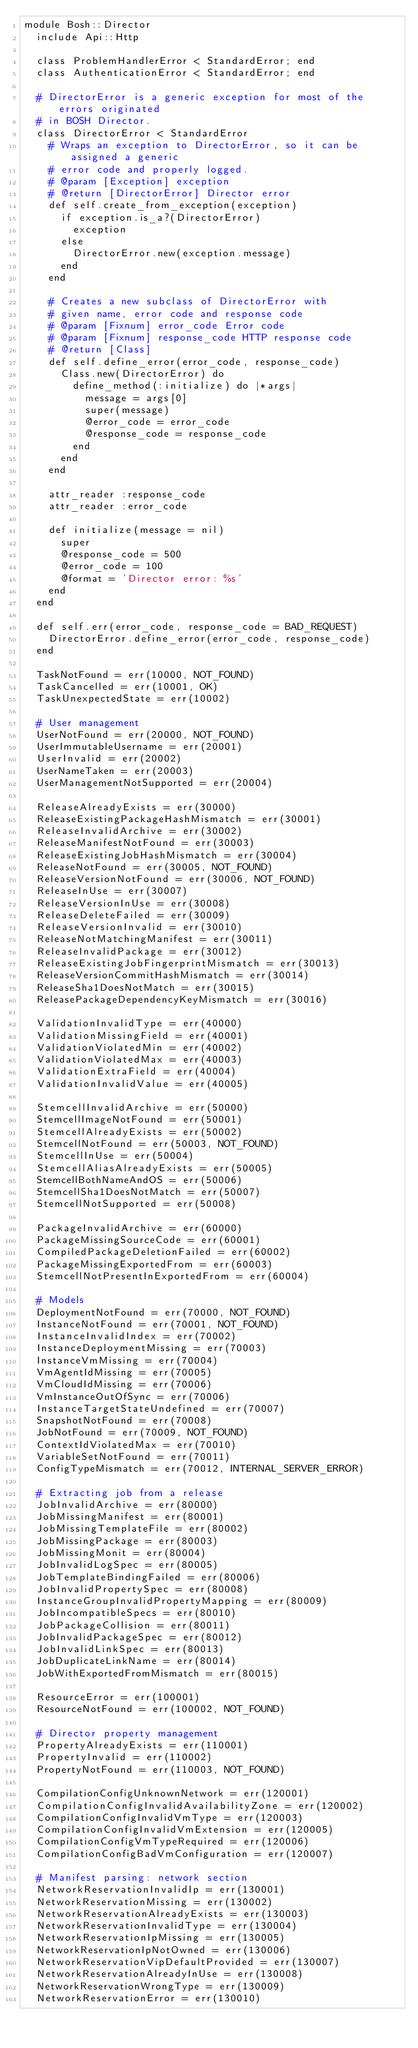<code> <loc_0><loc_0><loc_500><loc_500><_Ruby_>module Bosh::Director
  include Api::Http

  class ProblemHandlerError < StandardError; end
  class AuthenticationError < StandardError; end

  # DirectorError is a generic exception for most of the errors originated
  # in BOSH Director.
  class DirectorError < StandardError
    # Wraps an exception to DirectorError, so it can be assigned a generic
    # error code and properly logged.
    # @param [Exception] exception
    # @return [DirectorError] Director error
    def self.create_from_exception(exception)
      if exception.is_a?(DirectorError)
        exception
      else
        DirectorError.new(exception.message)
      end
    end

    # Creates a new subclass of DirectorError with
    # given name, error code and response code
    # @param [Fixnum] error_code Error code
    # @param [Fixnum] response_code HTTP response code
    # @return [Class]
    def self.define_error(error_code, response_code)
      Class.new(DirectorError) do
        define_method(:initialize) do |*args|
          message = args[0]
          super(message)
          @error_code = error_code
          @response_code = response_code
        end
      end
    end

    attr_reader :response_code
    attr_reader :error_code

    def initialize(message = nil)
      super
      @response_code = 500
      @error_code = 100
      @format = 'Director error: %s'
    end
  end

  def self.err(error_code, response_code = BAD_REQUEST)
    DirectorError.define_error(error_code, response_code)
  end

  TaskNotFound = err(10000, NOT_FOUND)
  TaskCancelled = err(10001, OK)
  TaskUnexpectedState = err(10002)

  # User management
  UserNotFound = err(20000, NOT_FOUND)
  UserImmutableUsername = err(20001)
  UserInvalid = err(20002)
  UserNameTaken = err(20003)
  UserManagementNotSupported = err(20004)

  ReleaseAlreadyExists = err(30000)
  ReleaseExistingPackageHashMismatch = err(30001)
  ReleaseInvalidArchive = err(30002)
  ReleaseManifestNotFound = err(30003)
  ReleaseExistingJobHashMismatch = err(30004)
  ReleaseNotFound = err(30005, NOT_FOUND)
  ReleaseVersionNotFound = err(30006, NOT_FOUND)
  ReleaseInUse = err(30007)
  ReleaseVersionInUse = err(30008)
  ReleaseDeleteFailed = err(30009)
  ReleaseVersionInvalid = err(30010)
  ReleaseNotMatchingManifest = err(30011)
  ReleaseInvalidPackage = err(30012)
  ReleaseExistingJobFingerprintMismatch = err(30013)
  ReleaseVersionCommitHashMismatch = err(30014)
  ReleaseSha1DoesNotMatch = err(30015)
  ReleasePackageDependencyKeyMismatch = err(30016)

  ValidationInvalidType = err(40000)
  ValidationMissingField = err(40001)
  ValidationViolatedMin = err(40002)
  ValidationViolatedMax = err(40003)
  ValidationExtraField = err(40004)
  ValidationInvalidValue = err(40005)

  StemcellInvalidArchive = err(50000)
  StemcellImageNotFound = err(50001)
  StemcellAlreadyExists = err(50002)
  StemcellNotFound = err(50003, NOT_FOUND)
  StemcellInUse = err(50004)
  StemcellAliasAlreadyExists = err(50005)
  StemcellBothNameAndOS = err(50006)
  StemcellSha1DoesNotMatch = err(50007)
  StemcellNotSupported = err(50008)

  PackageInvalidArchive = err(60000)
  PackageMissingSourceCode = err(60001)
  CompiledPackageDeletionFailed = err(60002)
  PackageMissingExportedFrom = err(60003)
  StemcellNotPresentInExportedFrom = err(60004)

  # Models
  DeploymentNotFound = err(70000, NOT_FOUND)
  InstanceNotFound = err(70001, NOT_FOUND)
  InstanceInvalidIndex = err(70002)
  InstanceDeploymentMissing = err(70003)
  InstanceVmMissing = err(70004)
  VmAgentIdMissing = err(70005)
  VmCloudIdMissing = err(70006)
  VmInstanceOutOfSync = err(70006)
  InstanceTargetStateUndefined = err(70007)
  SnapshotNotFound = err(70008)
  JobNotFound = err(70009, NOT_FOUND)
  ContextIdViolatedMax = err(70010)
  VariableSetNotFound = err(70011)
  ConfigTypeMismatch = err(70012, INTERNAL_SERVER_ERROR)

  # Extracting job from a release
  JobInvalidArchive = err(80000)
  JobMissingManifest = err(80001)
  JobMissingTemplateFile = err(80002)
  JobMissingPackage = err(80003)
  JobMissingMonit = err(80004)
  JobInvalidLogSpec = err(80005)
  JobTemplateBindingFailed = err(80006)
  JobInvalidPropertySpec = err(80008)
  InstanceGroupInvalidPropertyMapping = err(80009)
  JobIncompatibleSpecs = err(80010)
  JobPackageCollision = err(80011)
  JobInvalidPackageSpec = err(80012)
  JobInvalidLinkSpec = err(80013)
  JobDuplicateLinkName = err(80014)
  JobWithExportedFromMismatch = err(80015)

  ResourceError = err(100001)
  ResourceNotFound = err(100002, NOT_FOUND)

  # Director property management
  PropertyAlreadyExists = err(110001)
  PropertyInvalid = err(110002)
  PropertyNotFound = err(110003, NOT_FOUND)

  CompilationConfigUnknownNetwork = err(120001)
  CompilationConfigInvalidAvailabilityZone = err(120002)
  CompilationConfigInvalidVmType = err(120003)
  CompilationConfigInvalidVmExtension = err(120005)
  CompilationConfigVmTypeRequired = err(120006)
  CompilationConfigBadVmConfiguration = err(120007)

  # Manifest parsing: network section
  NetworkReservationInvalidIp = err(130001)
  NetworkReservationMissing = err(130002)
  NetworkReservationAlreadyExists = err(130003)
  NetworkReservationInvalidType = err(130004)
  NetworkReservationIpMissing = err(130005)
  NetworkReservationIpNotOwned = err(130006)
  NetworkReservationVipDefaultProvided = err(130007)
  NetworkReservationAlreadyInUse = err(130008)
  NetworkReservationWrongType = err(130009)
  NetworkReservationError = err(130010)</code> 